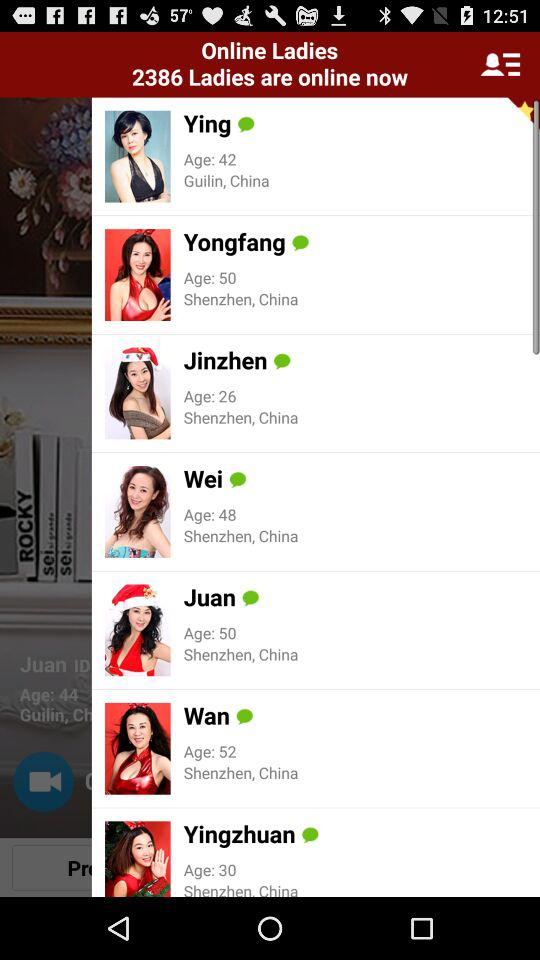How many ladies are online?
Answer the question using a single word or phrase. 2386 